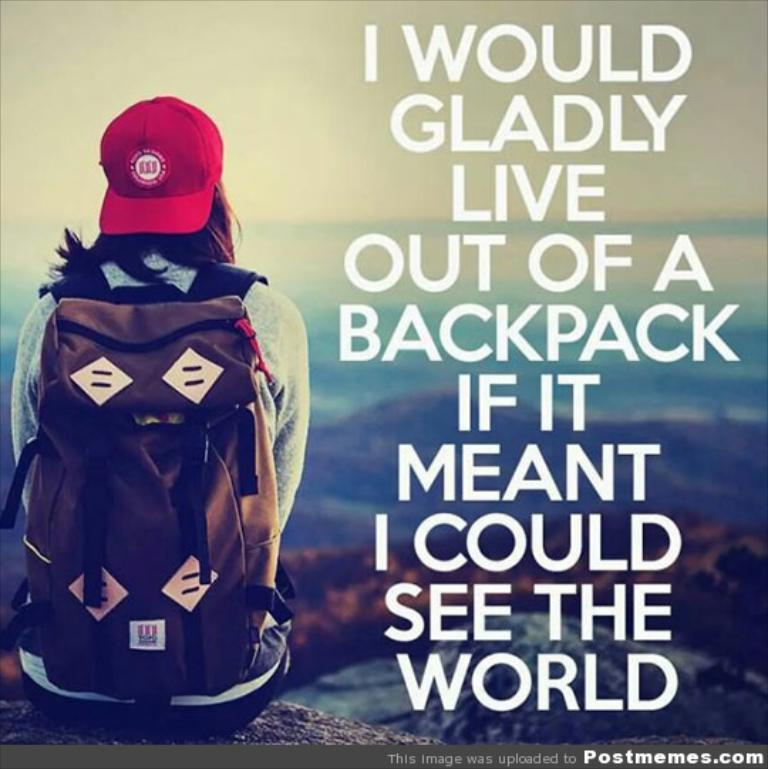What is the woman doing in the image? The woman is sitting on the left side of the image. What is the woman wearing on her back? The woman is wearing a backpack. What type of headwear is the woman wearing? The woman is wearing a red cap. What can be seen in the distance behind the woman? There are mountains visible in the background of the image. What type of oatmeal is the woman eating in the image? There is no oatmeal present in the image; the woman is wearing a backpack and a red cap while sitting on the left side of the image. What color is the boot the woman is wearing on her right foot? The image does not show the woman wearing any boots; she is wearing a backpack and a red cap while sitting on the left side of the image. 